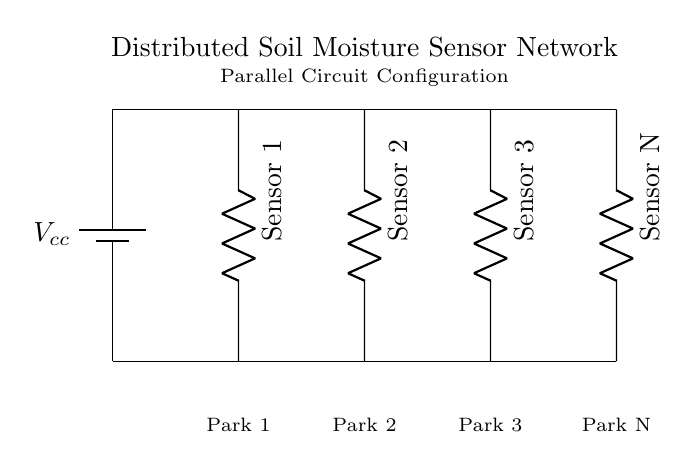What type of circuit is shown? The circuit is a parallel circuit because all components are connected across the same voltage source with their terminals connected at the same nodes.
Answer: Parallel How many sensors are displayed? The diagram indicates four soil moisture sensors, each associated with a specific park, as labeled in the circuit.
Answer: Four What is the function of the components in this circuit? The components, labeled as sensors, measure soil moisture levels for their respective parks, providing data for water conservation efforts in those areas.
Answer: Measure soil moisture What is the voltage source in the circuit? The voltage source is labeled Vcc, representing the supply voltage for the entire sensor network, likely providing a constant power supply to each sensor in parallel.
Answer: Vcc How are the sensors configured in relation to each other? The sensors are configured in parallel, meaning that each sensor operates independently while receiving the same voltage supply from the voltage source.
Answer: In parallel What is the purpose of using a parallel configuration for the sensors? A parallel configuration allows for independent measurement of each sensor, ensuring that if one sensor fails, the others continue to operate without affecting their functionality.
Answer: Independent measurement 